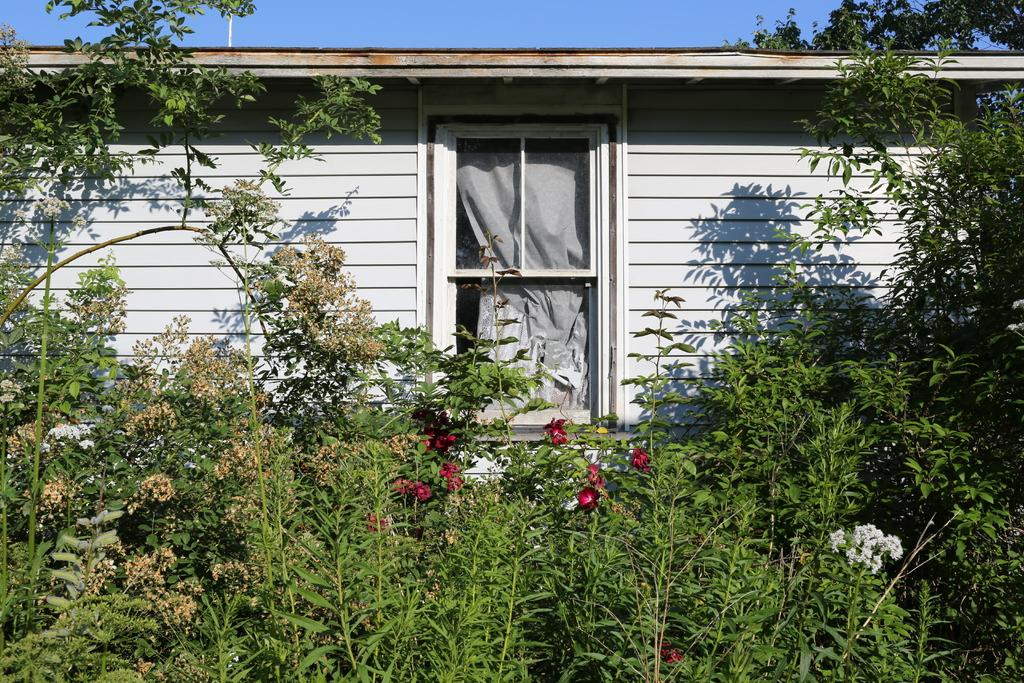What natural element is visible in the image? The sky is visible in the image. What can be seen in the sky in the image? Clouds are present in the image. What type of vegetation is visible in the image? Trees, plants, and flowers are visible in the image. What type of structure is present in the image? There is a wooden house in the image. What feature of the wooden house is visible in the image? A door is visible on the wooden house. What type of window treatment is present in the image? There is a curtain in the image. What scene is the achiever performing in the image? There is no scene or achiever present in the image. What type of ant can be seen interacting with the curtain in the image? There are no ants present in the image; it features a wooden house with a door and a curtain. 